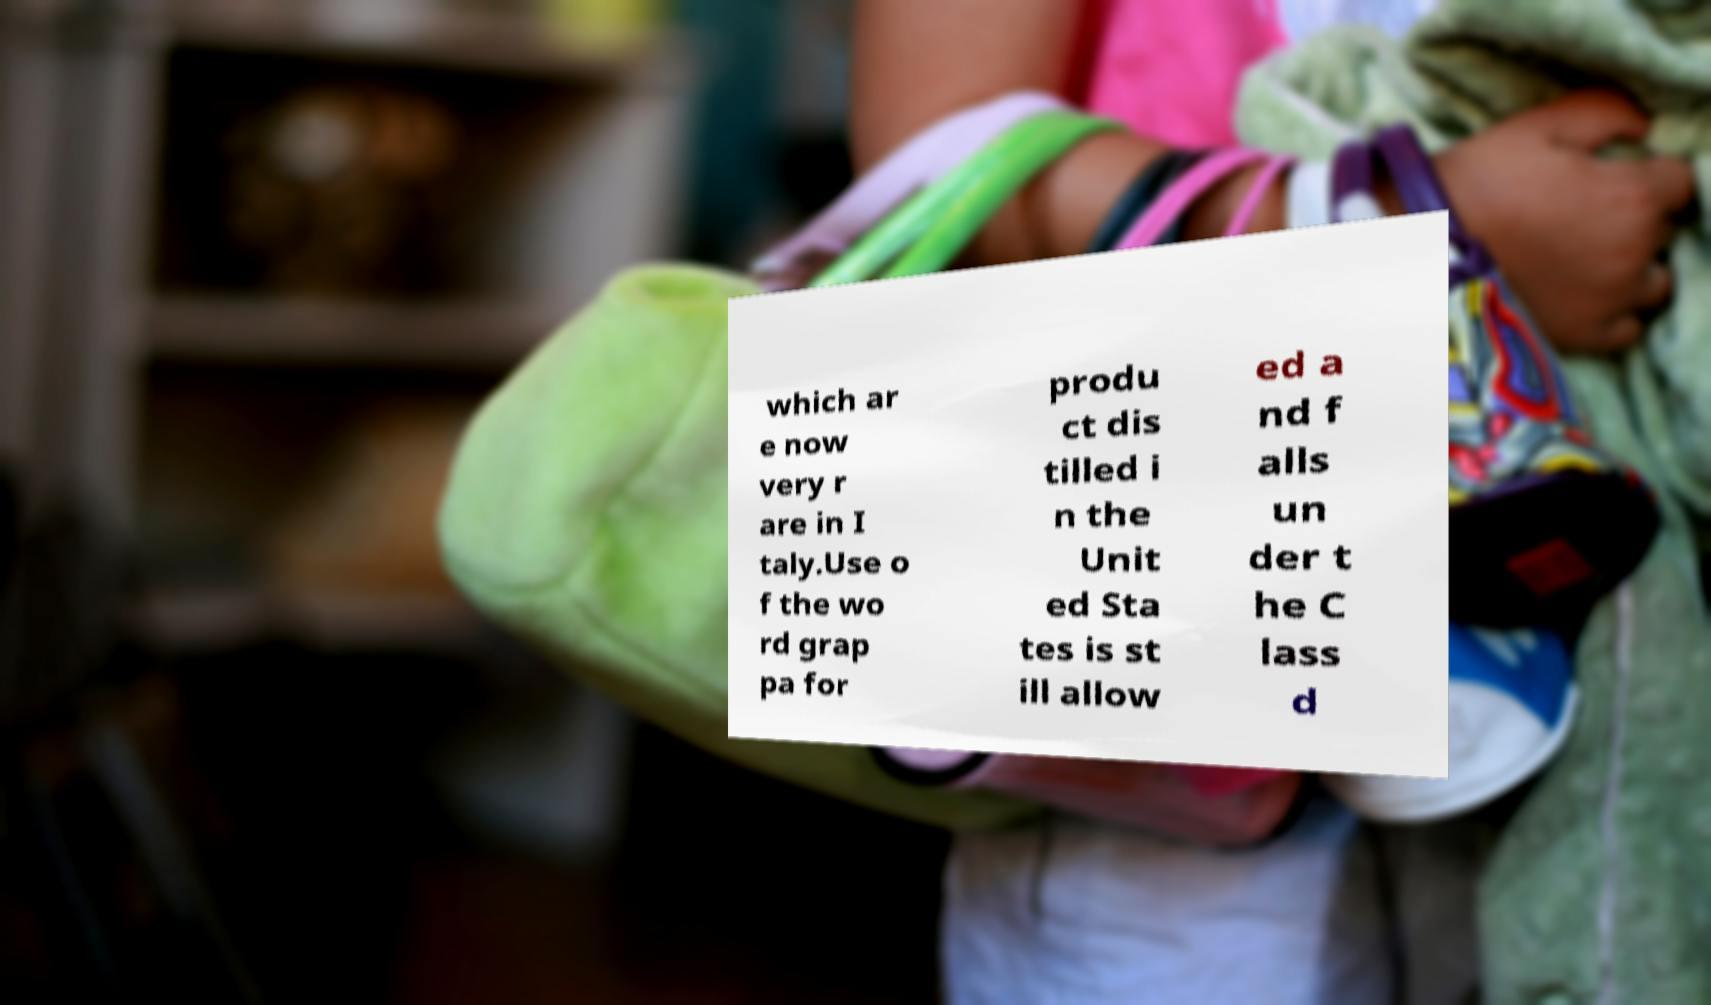For documentation purposes, I need the text within this image transcribed. Could you provide that? which ar e now very r are in I taly.Use o f the wo rd grap pa for produ ct dis tilled i n the Unit ed Sta tes is st ill allow ed a nd f alls un der t he C lass d 